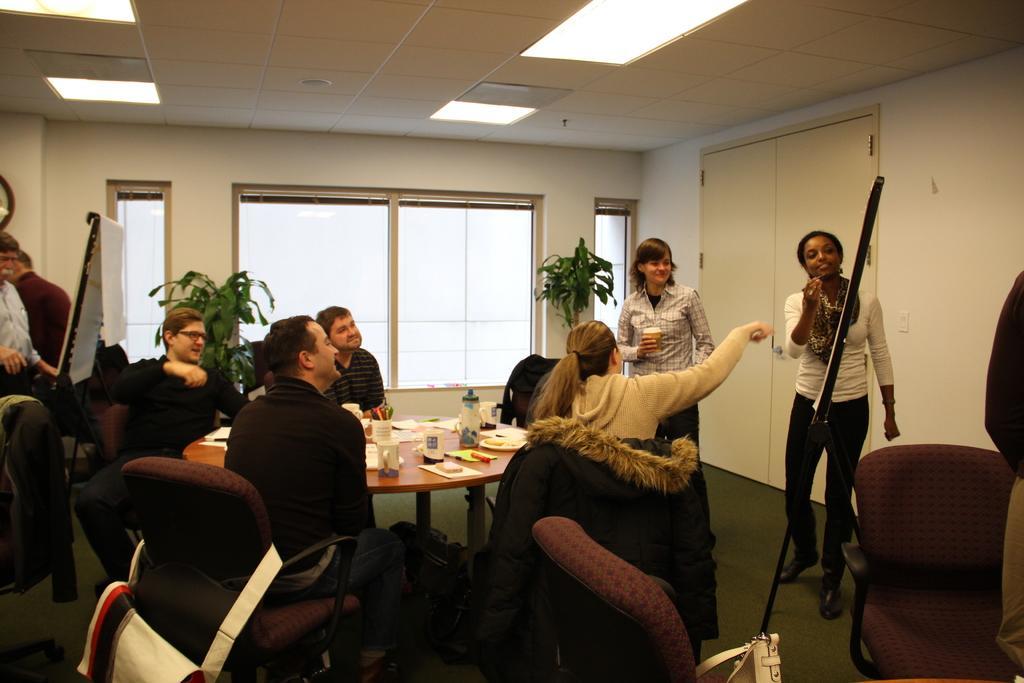Please provide a concise description of this image. In this image, there are group of peoples are there. Few are sat on the chairs ,few are standing and they are smiling together. At the background , we can see white door, wall, plants, windows and boards. At the bottom, we can see some bags. At the roof, we can see lights. 